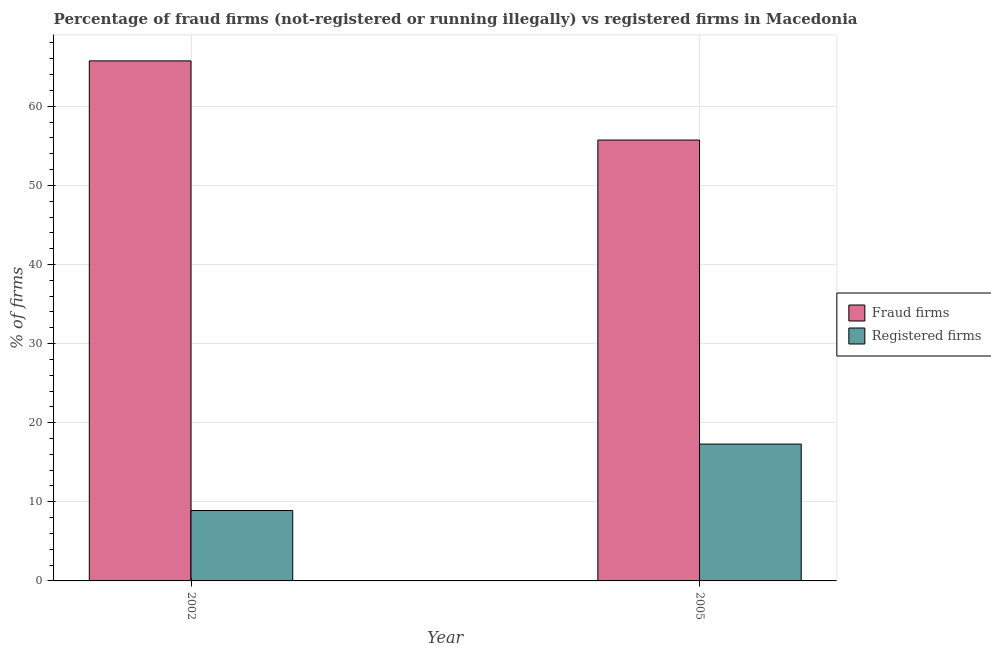Are the number of bars on each tick of the X-axis equal?
Offer a very short reply. Yes. How many bars are there on the 2nd tick from the right?
Offer a very short reply. 2. What is the label of the 2nd group of bars from the left?
Provide a succinct answer. 2005. What is the percentage of fraud firms in 2005?
Provide a short and direct response. 55.73. Across all years, what is the maximum percentage of fraud firms?
Give a very brief answer. 65.74. In which year was the percentage of fraud firms maximum?
Provide a succinct answer. 2002. What is the total percentage of registered firms in the graph?
Make the answer very short. 26.2. What is the difference between the percentage of fraud firms in 2002 and that in 2005?
Keep it short and to the point. 10.01. What is the difference between the percentage of fraud firms in 2005 and the percentage of registered firms in 2002?
Offer a very short reply. -10.01. What is the average percentage of fraud firms per year?
Offer a very short reply. 60.73. In the year 2002, what is the difference between the percentage of fraud firms and percentage of registered firms?
Your answer should be very brief. 0. In how many years, is the percentage of fraud firms greater than 38 %?
Provide a succinct answer. 2. What is the ratio of the percentage of registered firms in 2002 to that in 2005?
Provide a short and direct response. 0.51. Is the percentage of fraud firms in 2002 less than that in 2005?
Provide a succinct answer. No. What does the 2nd bar from the left in 2005 represents?
Provide a short and direct response. Registered firms. What does the 1st bar from the right in 2005 represents?
Make the answer very short. Registered firms. How many bars are there?
Make the answer very short. 4. Are all the bars in the graph horizontal?
Keep it short and to the point. No. What is the difference between two consecutive major ticks on the Y-axis?
Your response must be concise. 10. Does the graph contain any zero values?
Provide a succinct answer. No. What is the title of the graph?
Offer a terse response. Percentage of fraud firms (not-registered or running illegally) vs registered firms in Macedonia. Does "Health Care" appear as one of the legend labels in the graph?
Your answer should be compact. No. What is the label or title of the Y-axis?
Offer a very short reply. % of firms. What is the % of firms of Fraud firms in 2002?
Your answer should be very brief. 65.74. What is the % of firms of Registered firms in 2002?
Your response must be concise. 8.9. What is the % of firms in Fraud firms in 2005?
Offer a terse response. 55.73. What is the % of firms in Registered firms in 2005?
Offer a very short reply. 17.3. Across all years, what is the maximum % of firms in Fraud firms?
Provide a short and direct response. 65.74. Across all years, what is the maximum % of firms of Registered firms?
Keep it short and to the point. 17.3. Across all years, what is the minimum % of firms of Fraud firms?
Provide a succinct answer. 55.73. What is the total % of firms of Fraud firms in the graph?
Your response must be concise. 121.47. What is the total % of firms in Registered firms in the graph?
Offer a very short reply. 26.2. What is the difference between the % of firms of Fraud firms in 2002 and that in 2005?
Your response must be concise. 10.01. What is the difference between the % of firms of Registered firms in 2002 and that in 2005?
Make the answer very short. -8.4. What is the difference between the % of firms in Fraud firms in 2002 and the % of firms in Registered firms in 2005?
Your answer should be very brief. 48.44. What is the average % of firms in Fraud firms per year?
Your answer should be compact. 60.73. In the year 2002, what is the difference between the % of firms in Fraud firms and % of firms in Registered firms?
Provide a short and direct response. 56.84. In the year 2005, what is the difference between the % of firms of Fraud firms and % of firms of Registered firms?
Provide a succinct answer. 38.43. What is the ratio of the % of firms of Fraud firms in 2002 to that in 2005?
Your answer should be very brief. 1.18. What is the ratio of the % of firms of Registered firms in 2002 to that in 2005?
Offer a very short reply. 0.51. What is the difference between the highest and the second highest % of firms of Fraud firms?
Keep it short and to the point. 10.01. What is the difference between the highest and the second highest % of firms in Registered firms?
Make the answer very short. 8.4. What is the difference between the highest and the lowest % of firms of Fraud firms?
Provide a short and direct response. 10.01. What is the difference between the highest and the lowest % of firms of Registered firms?
Provide a succinct answer. 8.4. 